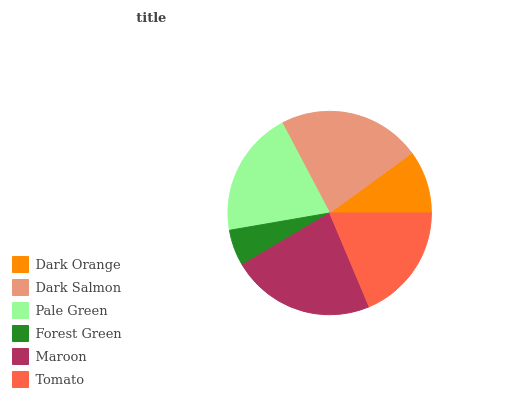Is Forest Green the minimum?
Answer yes or no. Yes. Is Maroon the maximum?
Answer yes or no. Yes. Is Dark Salmon the minimum?
Answer yes or no. No. Is Dark Salmon the maximum?
Answer yes or no. No. Is Dark Salmon greater than Dark Orange?
Answer yes or no. Yes. Is Dark Orange less than Dark Salmon?
Answer yes or no. Yes. Is Dark Orange greater than Dark Salmon?
Answer yes or no. No. Is Dark Salmon less than Dark Orange?
Answer yes or no. No. Is Pale Green the high median?
Answer yes or no. Yes. Is Tomato the low median?
Answer yes or no. Yes. Is Tomato the high median?
Answer yes or no. No. Is Dark Salmon the low median?
Answer yes or no. No. 